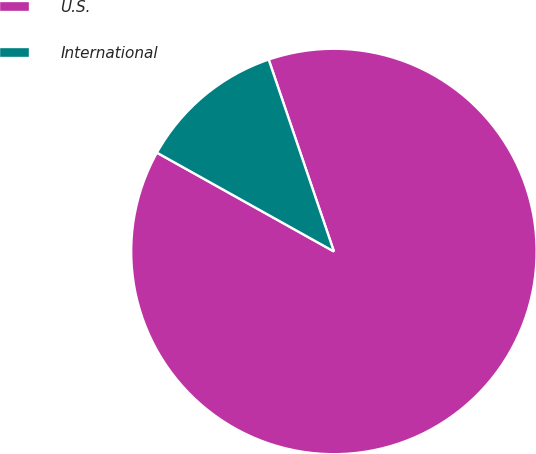<chart> <loc_0><loc_0><loc_500><loc_500><pie_chart><fcel>U.S.<fcel>International<nl><fcel>88.32%<fcel>11.68%<nl></chart> 